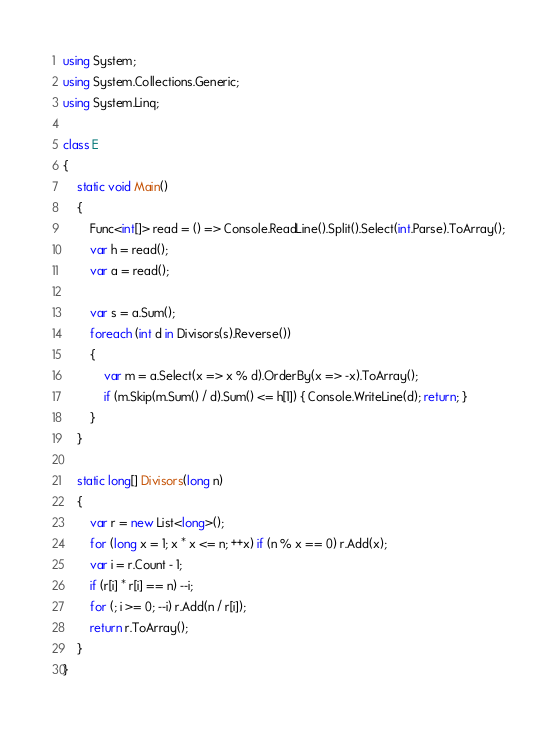Convert code to text. <code><loc_0><loc_0><loc_500><loc_500><_C#_>using System;
using System.Collections.Generic;
using System.Linq;

class E
{
	static void Main()
	{
		Func<int[]> read = () => Console.ReadLine().Split().Select(int.Parse).ToArray();
		var h = read();
		var a = read();

		var s = a.Sum();
		foreach (int d in Divisors(s).Reverse())
		{
			var m = a.Select(x => x % d).OrderBy(x => -x).ToArray();
			if (m.Skip(m.Sum() / d).Sum() <= h[1]) { Console.WriteLine(d); return; }
		}
	}

	static long[] Divisors(long n)
	{
		var r = new List<long>();
		for (long x = 1; x * x <= n; ++x) if (n % x == 0) r.Add(x);
		var i = r.Count - 1;
		if (r[i] * r[i] == n) --i;
		for (; i >= 0; --i) r.Add(n / r[i]);
		return r.ToArray();
	}
}
</code> 